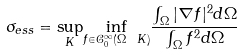Convert formula to latex. <formula><loc_0><loc_0><loc_500><loc_500>\sigma _ { e s s } = \underset { K } { \sup } \underset { f \in \mathcal { C } _ { 0 } ^ { \infty } ( \Omega \ K ) } { \inf } \frac { \int _ { \Omega } | \nabla f | ^ { 2 } d \Omega } { \int _ { \Omega } f ^ { 2 } d \Omega }</formula> 